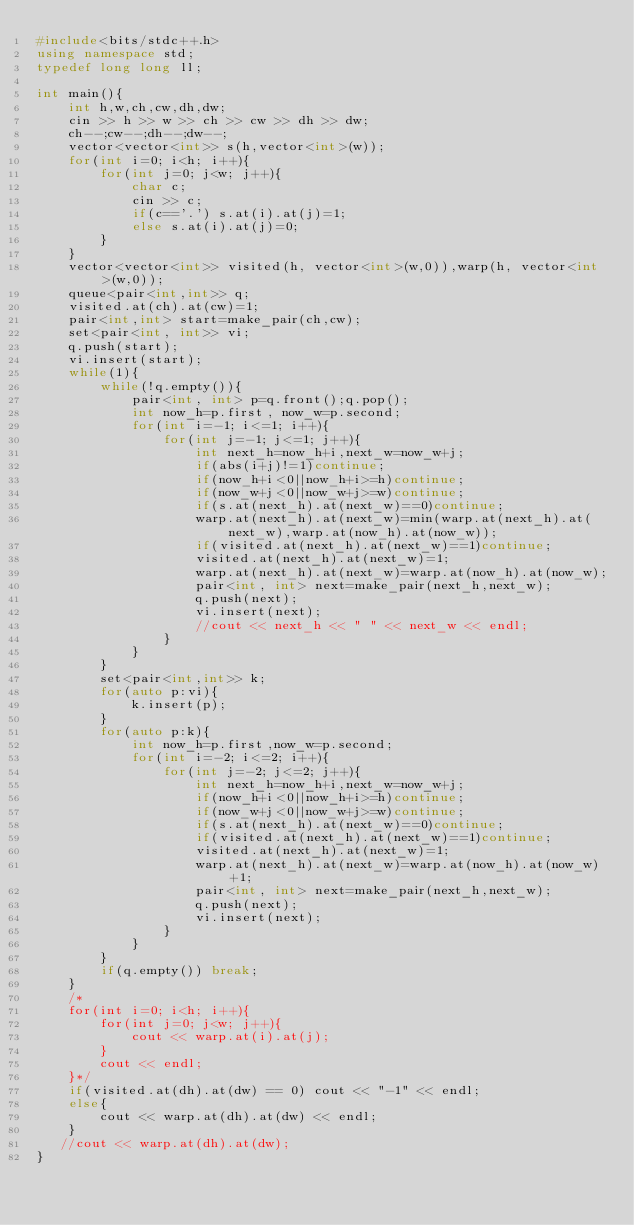Convert code to text. <code><loc_0><loc_0><loc_500><loc_500><_C++_>#include<bits/stdc++.h>
using namespace std;
typedef long long ll;

int main(){
    int h,w,ch,cw,dh,dw;
    cin >> h >> w >> ch >> cw >> dh >> dw;
    ch--;cw--;dh--;dw--;
    vector<vector<int>> s(h,vector<int>(w));
    for(int i=0; i<h; i++){
        for(int j=0; j<w; j++){
            char c;
            cin >> c;
            if(c=='.') s.at(i).at(j)=1;
            else s.at(i).at(j)=0;
        }
    }
    vector<vector<int>> visited(h, vector<int>(w,0)),warp(h, vector<int>(w,0));
    queue<pair<int,int>> q;
    visited.at(ch).at(cw)=1;
    pair<int,int> start=make_pair(ch,cw);
    set<pair<int, int>> vi;
    q.push(start);
    vi.insert(start);
    while(1){
        while(!q.empty()){
            pair<int, int> p=q.front();q.pop();
            int now_h=p.first, now_w=p.second;
            for(int i=-1; i<=1; i++){
                for(int j=-1; j<=1; j++){
                    int next_h=now_h+i,next_w=now_w+j;
                    if(abs(i+j)!=1)continue;
                    if(now_h+i<0||now_h+i>=h)continue;
                    if(now_w+j<0||now_w+j>=w)continue;
                    if(s.at(next_h).at(next_w)==0)continue;
                    warp.at(next_h).at(next_w)=min(warp.at(next_h).at(next_w),warp.at(now_h).at(now_w));
                    if(visited.at(next_h).at(next_w)==1)continue;
                    visited.at(next_h).at(next_w)=1;
                    warp.at(next_h).at(next_w)=warp.at(now_h).at(now_w);
                    pair<int, int> next=make_pair(next_h,next_w);
                    q.push(next);
                    vi.insert(next);
                    //cout << next_h << " " << next_w << endl;
                }
            }
        }
        set<pair<int,int>> k;
        for(auto p:vi){
            k.insert(p);
        }
        for(auto p:k){
            int now_h=p.first,now_w=p.second;
            for(int i=-2; i<=2; i++){
                for(int j=-2; j<=2; j++){
                    int next_h=now_h+i,next_w=now_w+j;
                    if(now_h+i<0||now_h+i>=h)continue;
                    if(now_w+j<0||now_w+j>=w)continue;
                    if(s.at(next_h).at(next_w)==0)continue;
                    if(visited.at(next_h).at(next_w)==1)continue;
                    visited.at(next_h).at(next_w)=1;
                    warp.at(next_h).at(next_w)=warp.at(now_h).at(now_w)+1;
                    pair<int, int> next=make_pair(next_h,next_w);
                    q.push(next);
                    vi.insert(next);
                }
            }
        }
        if(q.empty()) break;
    }
    /*
    for(int i=0; i<h; i++){
        for(int j=0; j<w; j++){
            cout << warp.at(i).at(j);
        }
        cout << endl;
    }*/
    if(visited.at(dh).at(dw) == 0) cout << "-1" << endl;
    else{
        cout << warp.at(dh).at(dw) << endl;
    }
   //cout << warp.at(dh).at(dw);
}
</code> 